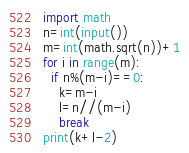Convert code to text. <code><loc_0><loc_0><loc_500><loc_500><_Python_>import math
n=int(input())
m=int(math.sqrt(n))+1
for i in range(m):
  if n%(m-i)==0:
    k=m-i
    l=n//(m-i)
    break
print(k+l-2)</code> 